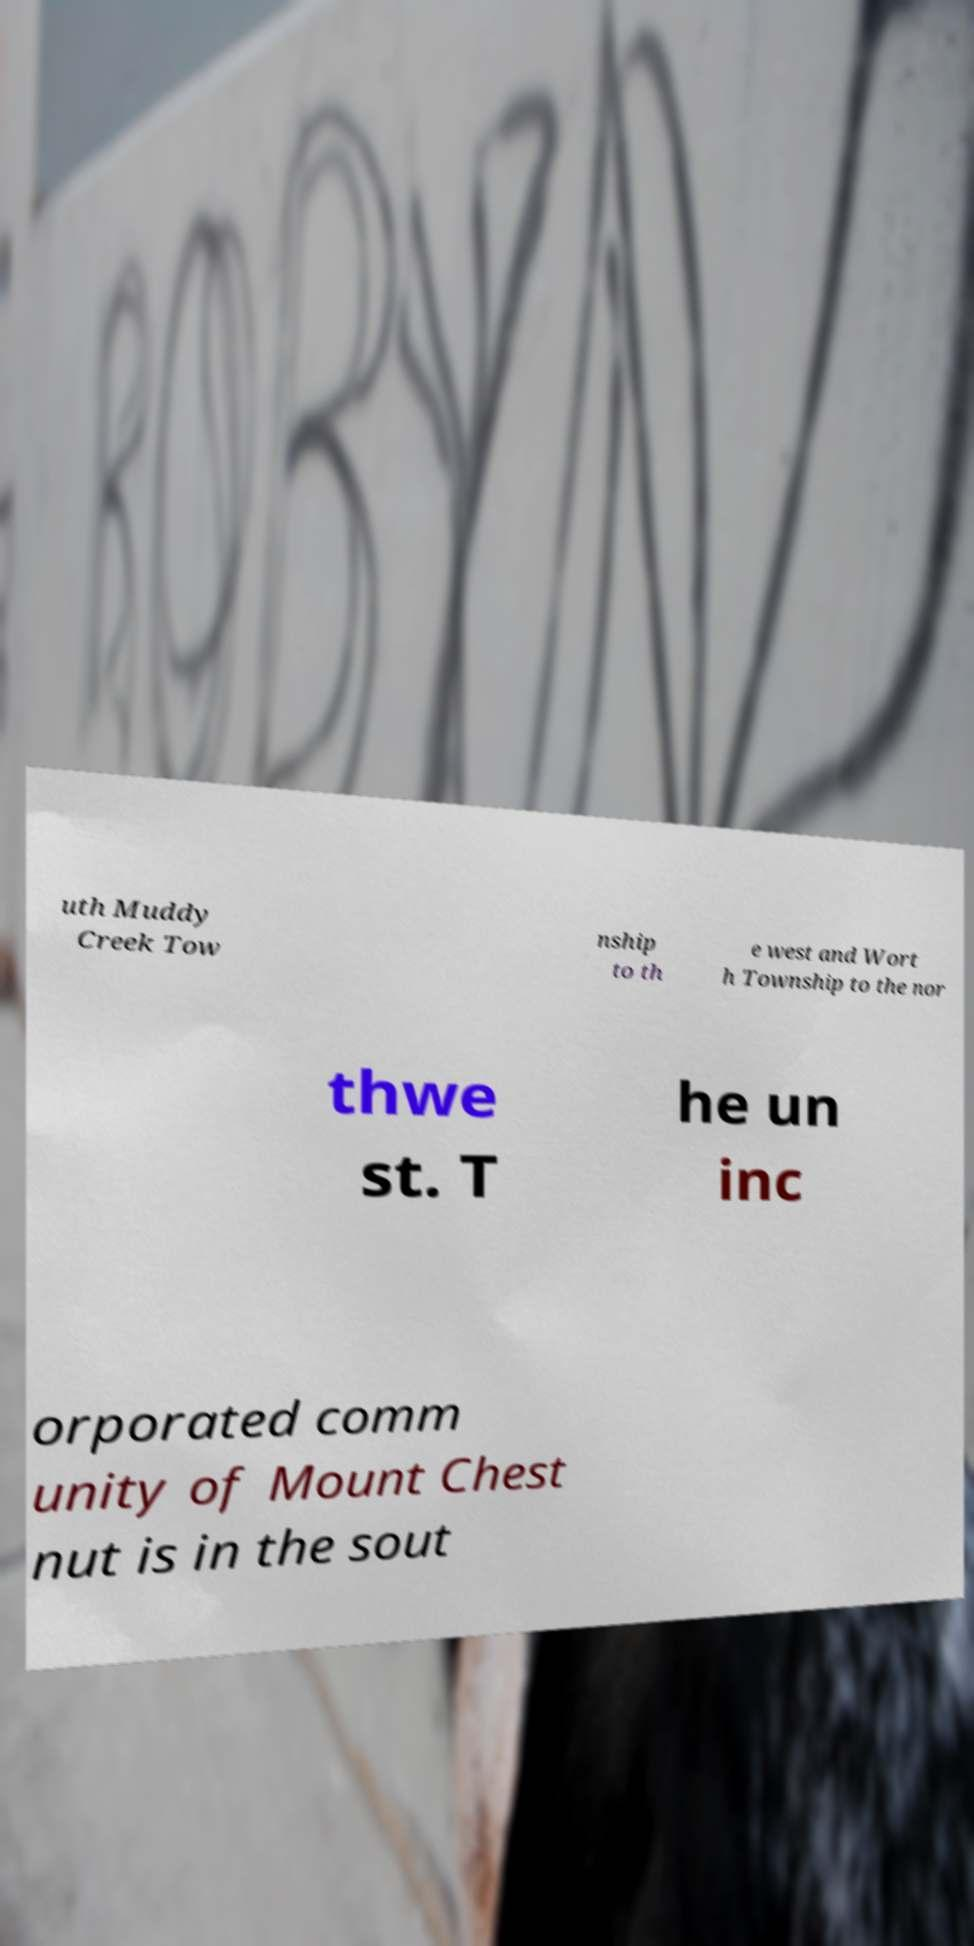For documentation purposes, I need the text within this image transcribed. Could you provide that? uth Muddy Creek Tow nship to th e west and Wort h Township to the nor thwe st. T he un inc orporated comm unity of Mount Chest nut is in the sout 